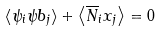Convert formula to latex. <formula><loc_0><loc_0><loc_500><loc_500>\left < \psi _ { i } \psi b _ { j } \right > + \left < \overline { N } _ { i } x _ { j } \right > = 0</formula> 